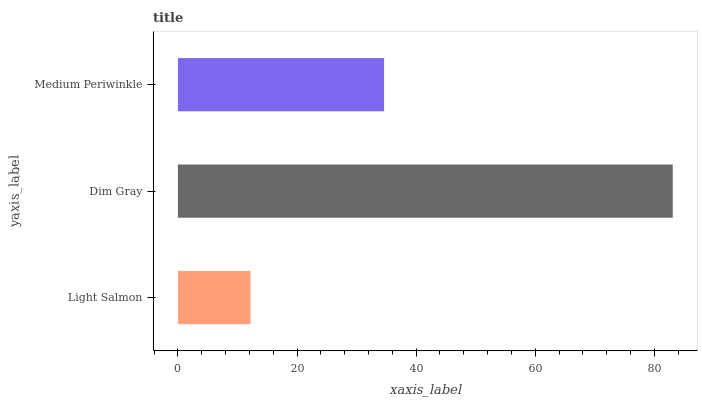Is Light Salmon the minimum?
Answer yes or no. Yes. Is Dim Gray the maximum?
Answer yes or no. Yes. Is Medium Periwinkle the minimum?
Answer yes or no. No. Is Medium Periwinkle the maximum?
Answer yes or no. No. Is Dim Gray greater than Medium Periwinkle?
Answer yes or no. Yes. Is Medium Periwinkle less than Dim Gray?
Answer yes or no. Yes. Is Medium Periwinkle greater than Dim Gray?
Answer yes or no. No. Is Dim Gray less than Medium Periwinkle?
Answer yes or no. No. Is Medium Periwinkle the high median?
Answer yes or no. Yes. Is Medium Periwinkle the low median?
Answer yes or no. Yes. Is Dim Gray the high median?
Answer yes or no. No. Is Dim Gray the low median?
Answer yes or no. No. 